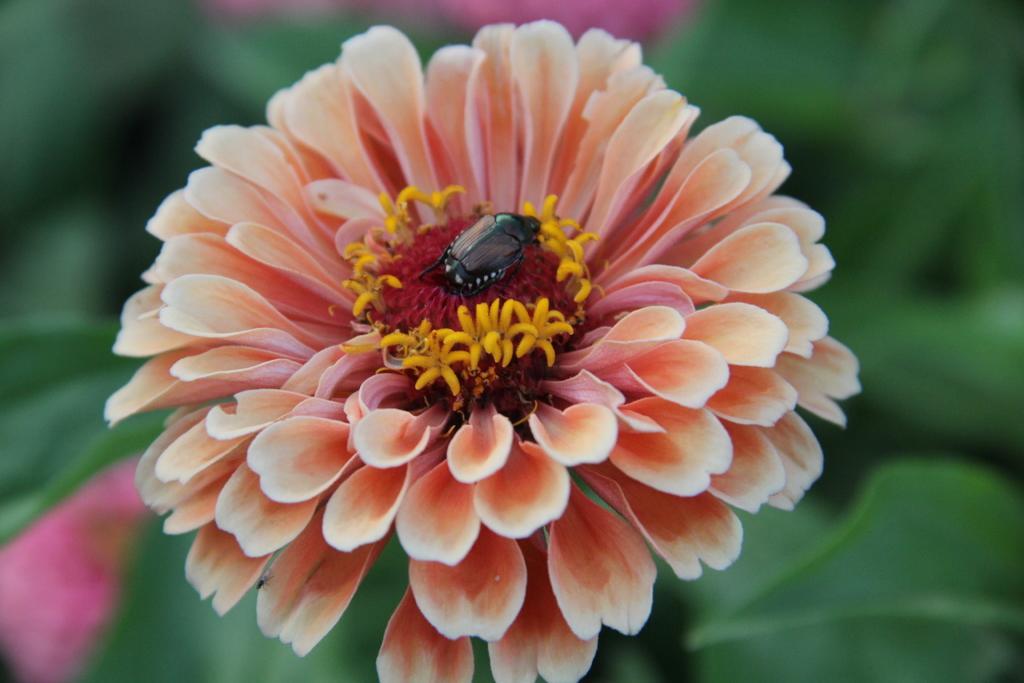Please provide a concise description of this image. In the image there is a flower and on the flower there is a small insect and the background of the flower is blue. 